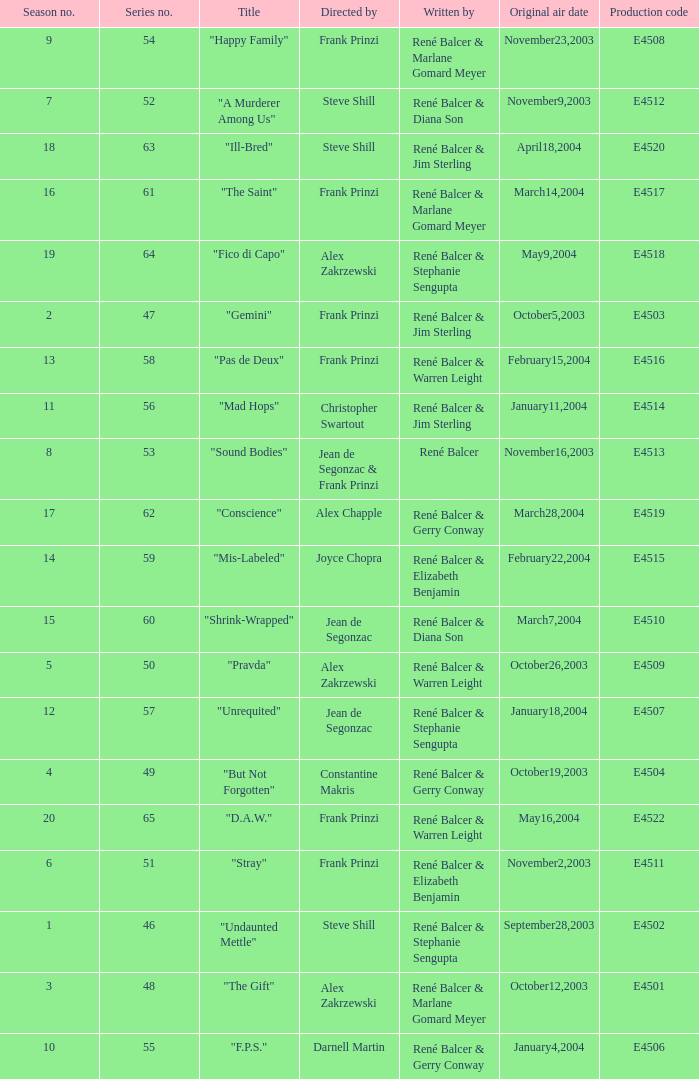Can you parse all the data within this table? {'header': ['Season no.', 'Series no.', 'Title', 'Directed by', 'Written by', 'Original air date', 'Production code'], 'rows': [['9', '54', '"Happy Family"', 'Frank Prinzi', 'René Balcer & Marlane Gomard Meyer', 'November23,2003', 'E4508'], ['7', '52', '"A Murderer Among Us"', 'Steve Shill', 'René Balcer & Diana Son', 'November9,2003', 'E4512'], ['18', '63', '"Ill-Bred"', 'Steve Shill', 'René Balcer & Jim Sterling', 'April18,2004', 'E4520'], ['16', '61', '"The Saint"', 'Frank Prinzi', 'René Balcer & Marlane Gomard Meyer', 'March14,2004', 'E4517'], ['19', '64', '"Fico di Capo"', 'Alex Zakrzewski', 'René Balcer & Stephanie Sengupta', 'May9,2004', 'E4518'], ['2', '47', '"Gemini"', 'Frank Prinzi', 'René Balcer & Jim Sterling', 'October5,2003', 'E4503'], ['13', '58', '"Pas de Deux"', 'Frank Prinzi', 'René Balcer & Warren Leight', 'February15,2004', 'E4516'], ['11', '56', '"Mad Hops"', 'Christopher Swartout', 'René Balcer & Jim Sterling', 'January11,2004', 'E4514'], ['8', '53', '"Sound Bodies"', 'Jean de Segonzac & Frank Prinzi', 'René Balcer', 'November16,2003', 'E4513'], ['17', '62', '"Conscience"', 'Alex Chapple', 'René Balcer & Gerry Conway', 'March28,2004', 'E4519'], ['14', '59', '"Mis-Labeled"', 'Joyce Chopra', 'René Balcer & Elizabeth Benjamin', 'February22,2004', 'E4515'], ['15', '60', '"Shrink-Wrapped"', 'Jean de Segonzac', 'René Balcer & Diana Son', 'March7,2004', 'E4510'], ['5', '50', '"Pravda"', 'Alex Zakrzewski', 'René Balcer & Warren Leight', 'October26,2003', 'E4509'], ['12', '57', '"Unrequited"', 'Jean de Segonzac', 'René Balcer & Stephanie Sengupta', 'January18,2004', 'E4507'], ['4', '49', '"But Not Forgotten"', 'Constantine Makris', 'René Balcer & Gerry Conway', 'October19,2003', 'E4504'], ['20', '65', '"D.A.W."', 'Frank Prinzi', 'René Balcer & Warren Leight', 'May16,2004', 'E4522'], ['6', '51', '"Stray"', 'Frank Prinzi', 'René Balcer & Elizabeth Benjamin', 'November2,2003', 'E4511'], ['1', '46', '"Undaunted Mettle"', 'Steve Shill', 'René Balcer & Stephanie Sengupta', 'September28,2003', 'E4502'], ['3', '48', '"The Gift"', 'Alex Zakrzewski', 'René Balcer & Marlane Gomard Meyer', 'October12,2003', 'E4501'], ['10', '55', '"F.P.S."', 'Darnell Martin', 'René Balcer & Gerry Conway', 'January4,2004', 'E4506']]} Who wrote the episode with e4515 as the production code? René Balcer & Elizabeth Benjamin. 